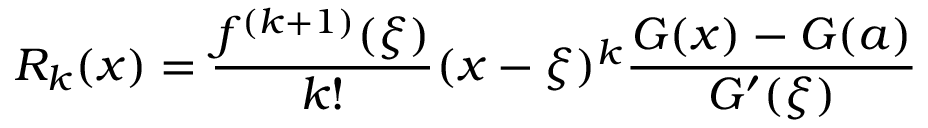Convert formula to latex. <formula><loc_0><loc_0><loc_500><loc_500>R _ { k } ( x ) = { \frac { f ^ { ( k + 1 ) } ( \xi ) } { k ! } } ( x - \xi ) ^ { k } { \frac { G ( x ) - G ( a ) } { G ^ { \prime } ( \xi ) } }</formula> 